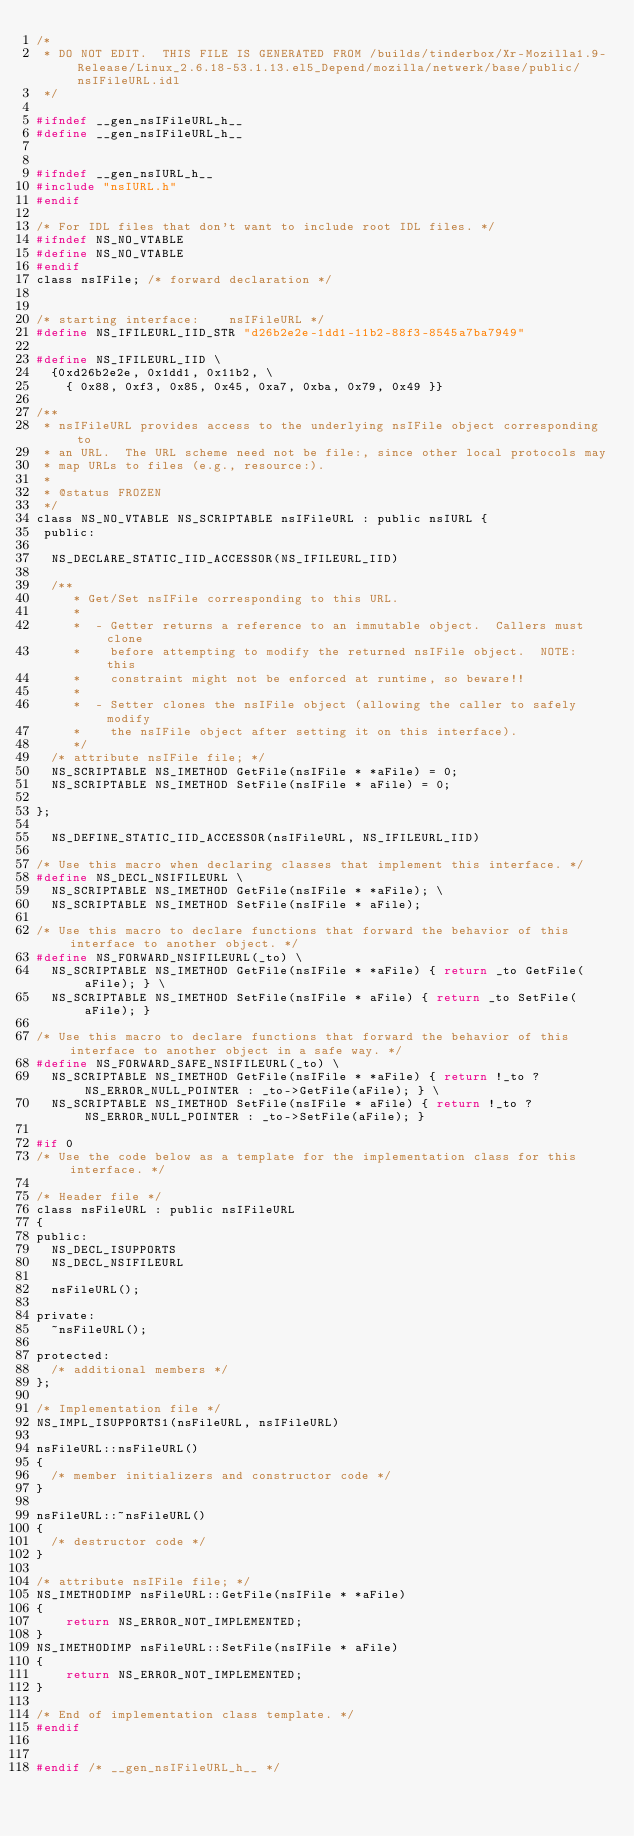<code> <loc_0><loc_0><loc_500><loc_500><_C_>/*
 * DO NOT EDIT.  THIS FILE IS GENERATED FROM /builds/tinderbox/Xr-Mozilla1.9-Release/Linux_2.6.18-53.1.13.el5_Depend/mozilla/netwerk/base/public/nsIFileURL.idl
 */

#ifndef __gen_nsIFileURL_h__
#define __gen_nsIFileURL_h__


#ifndef __gen_nsIURL_h__
#include "nsIURL.h"
#endif

/* For IDL files that don't want to include root IDL files. */
#ifndef NS_NO_VTABLE
#define NS_NO_VTABLE
#endif
class nsIFile; /* forward declaration */


/* starting interface:    nsIFileURL */
#define NS_IFILEURL_IID_STR "d26b2e2e-1dd1-11b2-88f3-8545a7ba7949"

#define NS_IFILEURL_IID \
  {0xd26b2e2e, 0x1dd1, 0x11b2, \
    { 0x88, 0xf3, 0x85, 0x45, 0xa7, 0xba, 0x79, 0x49 }}

/**
 * nsIFileURL provides access to the underlying nsIFile object corresponding to
 * an URL.  The URL scheme need not be file:, since other local protocols may
 * map URLs to files (e.g., resource:).
 *
 * @status FROZEN
 */
class NS_NO_VTABLE NS_SCRIPTABLE nsIFileURL : public nsIURL {
 public: 

  NS_DECLARE_STATIC_IID_ACCESSOR(NS_IFILEURL_IID)

  /**
     * Get/Set nsIFile corresponding to this URL.
     *
     *  - Getter returns a reference to an immutable object.  Callers must clone
     *    before attempting to modify the returned nsIFile object.  NOTE: this
     *    constraint might not be enforced at runtime, so beware!!
     *
     *  - Setter clones the nsIFile object (allowing the caller to safely modify
     *    the nsIFile object after setting it on this interface).
     */
  /* attribute nsIFile file; */
  NS_SCRIPTABLE NS_IMETHOD GetFile(nsIFile * *aFile) = 0;
  NS_SCRIPTABLE NS_IMETHOD SetFile(nsIFile * aFile) = 0;

};

  NS_DEFINE_STATIC_IID_ACCESSOR(nsIFileURL, NS_IFILEURL_IID)

/* Use this macro when declaring classes that implement this interface. */
#define NS_DECL_NSIFILEURL \
  NS_SCRIPTABLE NS_IMETHOD GetFile(nsIFile * *aFile); \
  NS_SCRIPTABLE NS_IMETHOD SetFile(nsIFile * aFile); 

/* Use this macro to declare functions that forward the behavior of this interface to another object. */
#define NS_FORWARD_NSIFILEURL(_to) \
  NS_SCRIPTABLE NS_IMETHOD GetFile(nsIFile * *aFile) { return _to GetFile(aFile); } \
  NS_SCRIPTABLE NS_IMETHOD SetFile(nsIFile * aFile) { return _to SetFile(aFile); } 

/* Use this macro to declare functions that forward the behavior of this interface to another object in a safe way. */
#define NS_FORWARD_SAFE_NSIFILEURL(_to) \
  NS_SCRIPTABLE NS_IMETHOD GetFile(nsIFile * *aFile) { return !_to ? NS_ERROR_NULL_POINTER : _to->GetFile(aFile); } \
  NS_SCRIPTABLE NS_IMETHOD SetFile(nsIFile * aFile) { return !_to ? NS_ERROR_NULL_POINTER : _to->SetFile(aFile); } 

#if 0
/* Use the code below as a template for the implementation class for this interface. */

/* Header file */
class nsFileURL : public nsIFileURL
{
public:
  NS_DECL_ISUPPORTS
  NS_DECL_NSIFILEURL

  nsFileURL();

private:
  ~nsFileURL();

protected:
  /* additional members */
};

/* Implementation file */
NS_IMPL_ISUPPORTS1(nsFileURL, nsIFileURL)

nsFileURL::nsFileURL()
{
  /* member initializers and constructor code */
}

nsFileURL::~nsFileURL()
{
  /* destructor code */
}

/* attribute nsIFile file; */
NS_IMETHODIMP nsFileURL::GetFile(nsIFile * *aFile)
{
    return NS_ERROR_NOT_IMPLEMENTED;
}
NS_IMETHODIMP nsFileURL::SetFile(nsIFile * aFile)
{
    return NS_ERROR_NOT_IMPLEMENTED;
}

/* End of implementation class template. */
#endif


#endif /* __gen_nsIFileURL_h__ */
</code> 